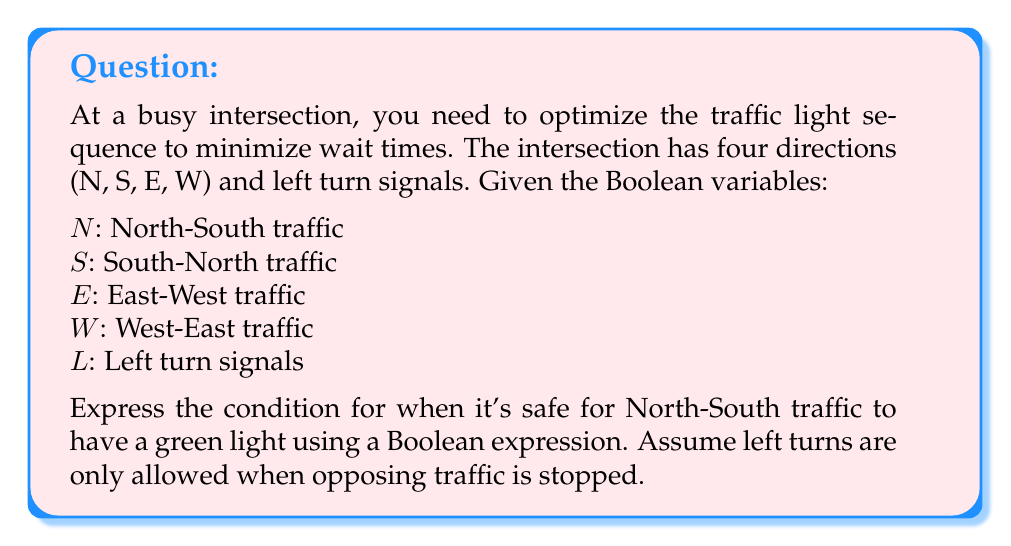Show me your answer to this math problem. Let's break this down step-by-step:

1) For North-South traffic to have a green light, East-West traffic must be stopped. This means $E$ and $W$ must be false:
   $\neg E \land \neg W$

2) Left turns from East or West must also be stopped:
   $\neg L$

3) Either North-South traffic or South-North traffic (or both) should be allowed:
   $N \lor S$

4) Combining these conditions using the AND operator:
   $(N \lor S) \land \neg E \land \neg W \land \neg L$

5) This expression can be simplified using Boolean algebra laws:
   $$(N \lor S) \land \neg(E \lor W \lor L)$$

This final expression represents the condition when it's safe for North-South traffic to have a green light.
Answer: $(N \lor S) \land \neg(E \lor W \lor L)$ 